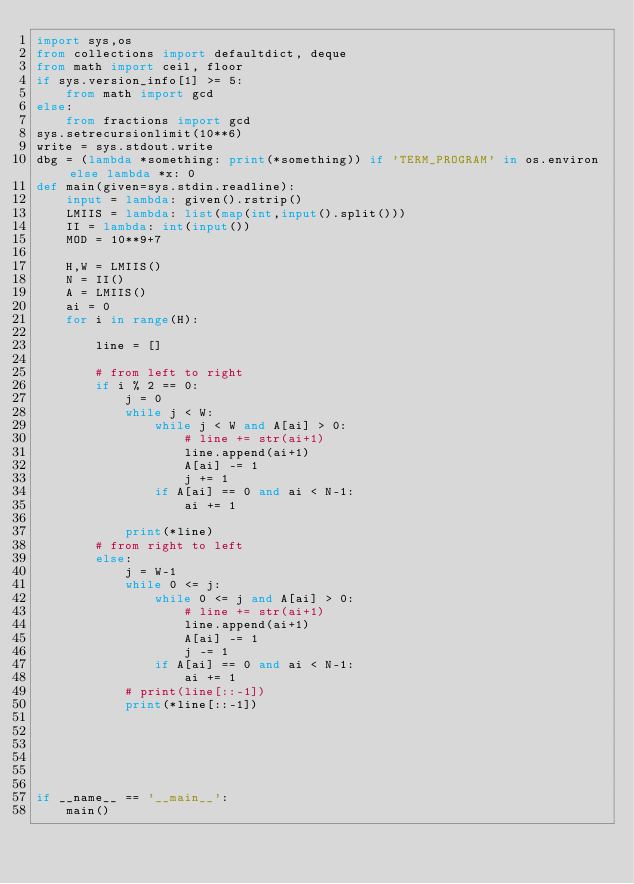<code> <loc_0><loc_0><loc_500><loc_500><_Python_>import sys,os
from collections import defaultdict, deque
from math import ceil, floor
if sys.version_info[1] >= 5:
    from math import gcd
else:
    from fractions import gcd
sys.setrecursionlimit(10**6)
write = sys.stdout.write
dbg = (lambda *something: print(*something)) if 'TERM_PROGRAM' in os.environ else lambda *x: 0
def main(given=sys.stdin.readline):
    input = lambda: given().rstrip()
    LMIIS = lambda: list(map(int,input().split()))
    II = lambda: int(input())
    MOD = 10**9+7

    H,W = LMIIS()
    N = II()
    A = LMIIS()
    ai = 0
    for i in range(H):
        
        line = []

        # from left to right
        if i % 2 == 0:
            j = 0
            while j < W:
                while j < W and A[ai] > 0:
                    # line += str(ai+1)
                    line.append(ai+1)
                    A[ai] -= 1
                    j += 1
                if A[ai] == 0 and ai < N-1:
                    ai += 1

            print(*line)
        # from right to left
        else:
            j = W-1
            while 0 <= j:
                while 0 <= j and A[ai] > 0:
                    # line += str(ai+1)
                    line.append(ai+1)
                    A[ai] -= 1
                    j -= 1
                if A[ai] == 0 and ai < N-1:
                    ai += 1
            # print(line[::-1])
            print(*line[::-1])




    

if __name__ == '__main__':
    main()</code> 